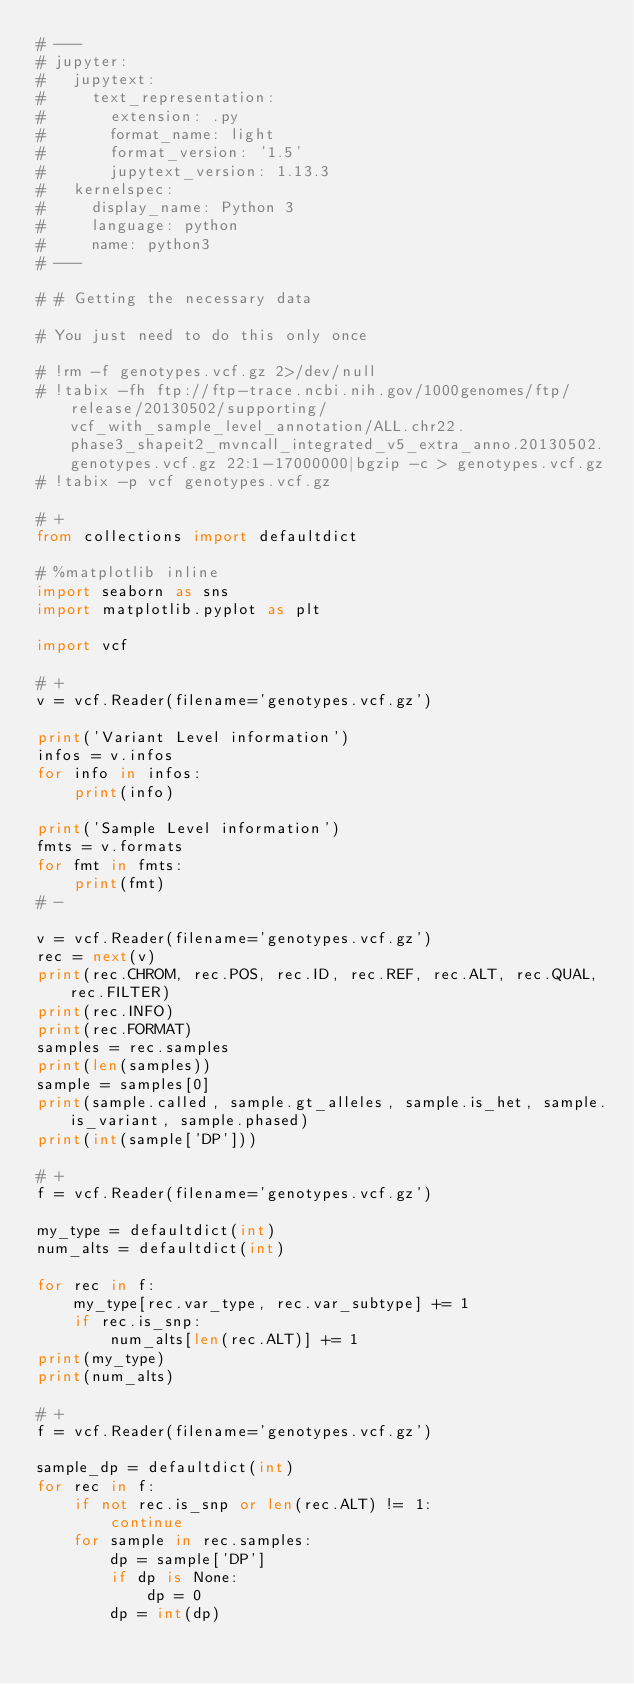<code> <loc_0><loc_0><loc_500><loc_500><_Python_># ---
# jupyter:
#   jupytext:
#     text_representation:
#       extension: .py
#       format_name: light
#       format_version: '1.5'
#       jupytext_version: 1.13.3
#   kernelspec:
#     display_name: Python 3
#     language: python
#     name: python3
# ---

# # Getting the necessary data

# You just need to do this only once

# !rm -f genotypes.vcf.gz 2>/dev/null
# !tabix -fh ftp://ftp-trace.ncbi.nih.gov/1000genomes/ftp/release/20130502/supporting/vcf_with_sample_level_annotation/ALL.chr22.phase3_shapeit2_mvncall_integrated_v5_extra_anno.20130502.genotypes.vcf.gz 22:1-17000000|bgzip -c > genotypes.vcf.gz
# !tabix -p vcf genotypes.vcf.gz

# +
from collections import defaultdict

# %matplotlib inline
import seaborn as sns
import matplotlib.pyplot as plt

import vcf

# +
v = vcf.Reader(filename='genotypes.vcf.gz')

print('Variant Level information')
infos = v.infos
for info in infos:
    print(info)

print('Sample Level information')
fmts = v.formats
for fmt in fmts:
    print(fmt)
# -

v = vcf.Reader(filename='genotypes.vcf.gz')
rec = next(v)
print(rec.CHROM, rec.POS, rec.ID, rec.REF, rec.ALT, rec.QUAL, rec.FILTER)
print(rec.INFO)
print(rec.FORMAT)
samples = rec.samples
print(len(samples))
sample = samples[0]
print(sample.called, sample.gt_alleles, sample.is_het, sample.is_variant, sample.phased)
print(int(sample['DP']))

# +
f = vcf.Reader(filename='genotypes.vcf.gz')

my_type = defaultdict(int)
num_alts = defaultdict(int)

for rec in f:
    my_type[rec.var_type, rec.var_subtype] += 1
    if rec.is_snp:
        num_alts[len(rec.ALT)] += 1
print(my_type)
print(num_alts)

# +
f = vcf.Reader(filename='genotypes.vcf.gz')

sample_dp = defaultdict(int)
for rec in f:
    if not rec.is_snp or len(rec.ALT) != 1:
        continue
    for sample in rec.samples:
        dp = sample['DP']
        if dp is None:
            dp = 0
        dp = int(dp)</code> 